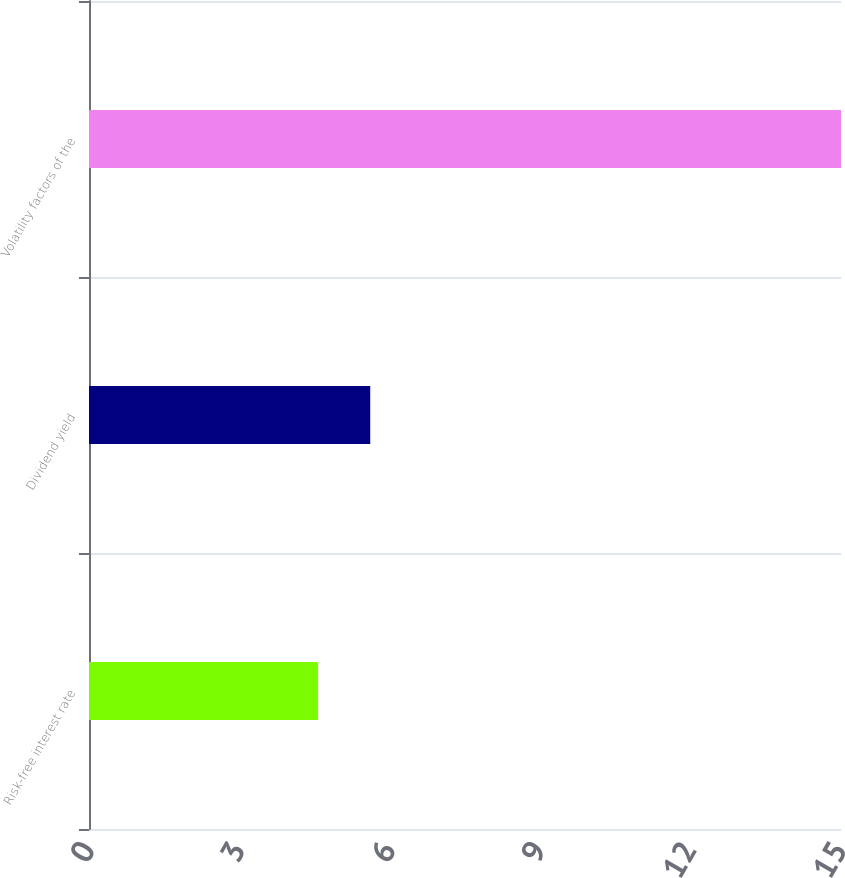<chart> <loc_0><loc_0><loc_500><loc_500><bar_chart><fcel>Risk-free interest rate<fcel>Dividend yield<fcel>Volatility factors of the<nl><fcel>4.57<fcel>5.61<fcel>15<nl></chart> 